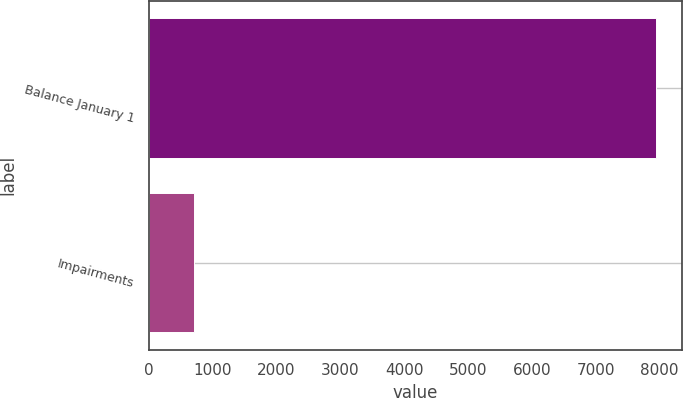Convert chart to OTSL. <chart><loc_0><loc_0><loc_500><loc_500><bar_chart><fcel>Balance January 1<fcel>Impairments<nl><fcel>7950<fcel>700<nl></chart> 